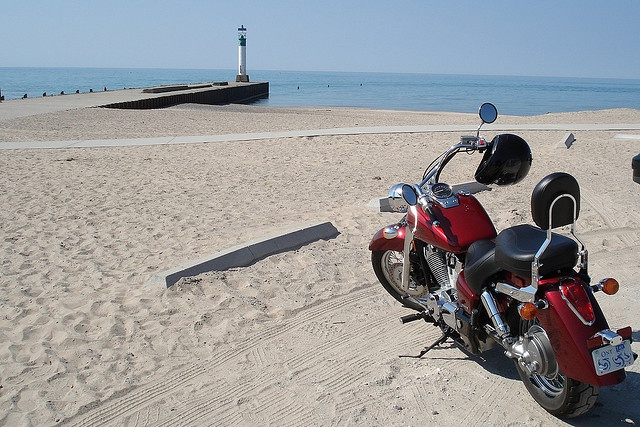Describe the objects in this image and their specific colors. I can see a motorcycle in lightblue, black, maroon, gray, and darkgray tones in this image. 